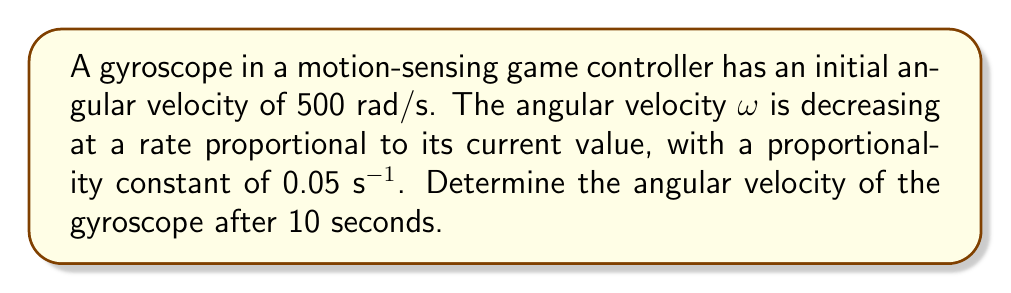Solve this math problem. To solve this problem, we need to use a first-order differential equation. Let's approach this step-by-step:

1) We're given that the rate of change of angular velocity is proportional to its current value. This can be expressed as:

   $$\frac{d\omega}{dt} = -k\omega$$

   where $k$ is the proportionality constant, 0.05 s^(-1).

2) This is a separable differential equation. We can separate the variables:

   $$\frac{d\omega}{\omega} = -k dt$$

3) Integrating both sides:

   $$\int \frac{d\omega}{\omega} = -k \int dt$$

   $$\ln|\omega| = -kt + C$$

4) We can express this in exponential form:

   $$\omega = Ae^{-kt}$$

   where $A$ is a constant we need to determine.

5) We know the initial condition: when $t=0$, $\omega = 500$ rad/s. Using this:

   $$500 = Ae^{-k(0)} = A$$

6) So our solution is:

   $$\omega = 500e^{-0.05t}$$

7) To find the angular velocity after 10 seconds, we substitute $t=10$:

   $$\omega = 500e^{-0.05(10)} = 500e^{-0.5}$$

8) Calculating this:

   $$\omega = 500 * 0.6065 = 303.25$$ rad/s

Therefore, after 10 seconds, the angular velocity of the gyroscope will be approximately 303.25 rad/s.
Answer: $\omega = 303.25$ rad/s 